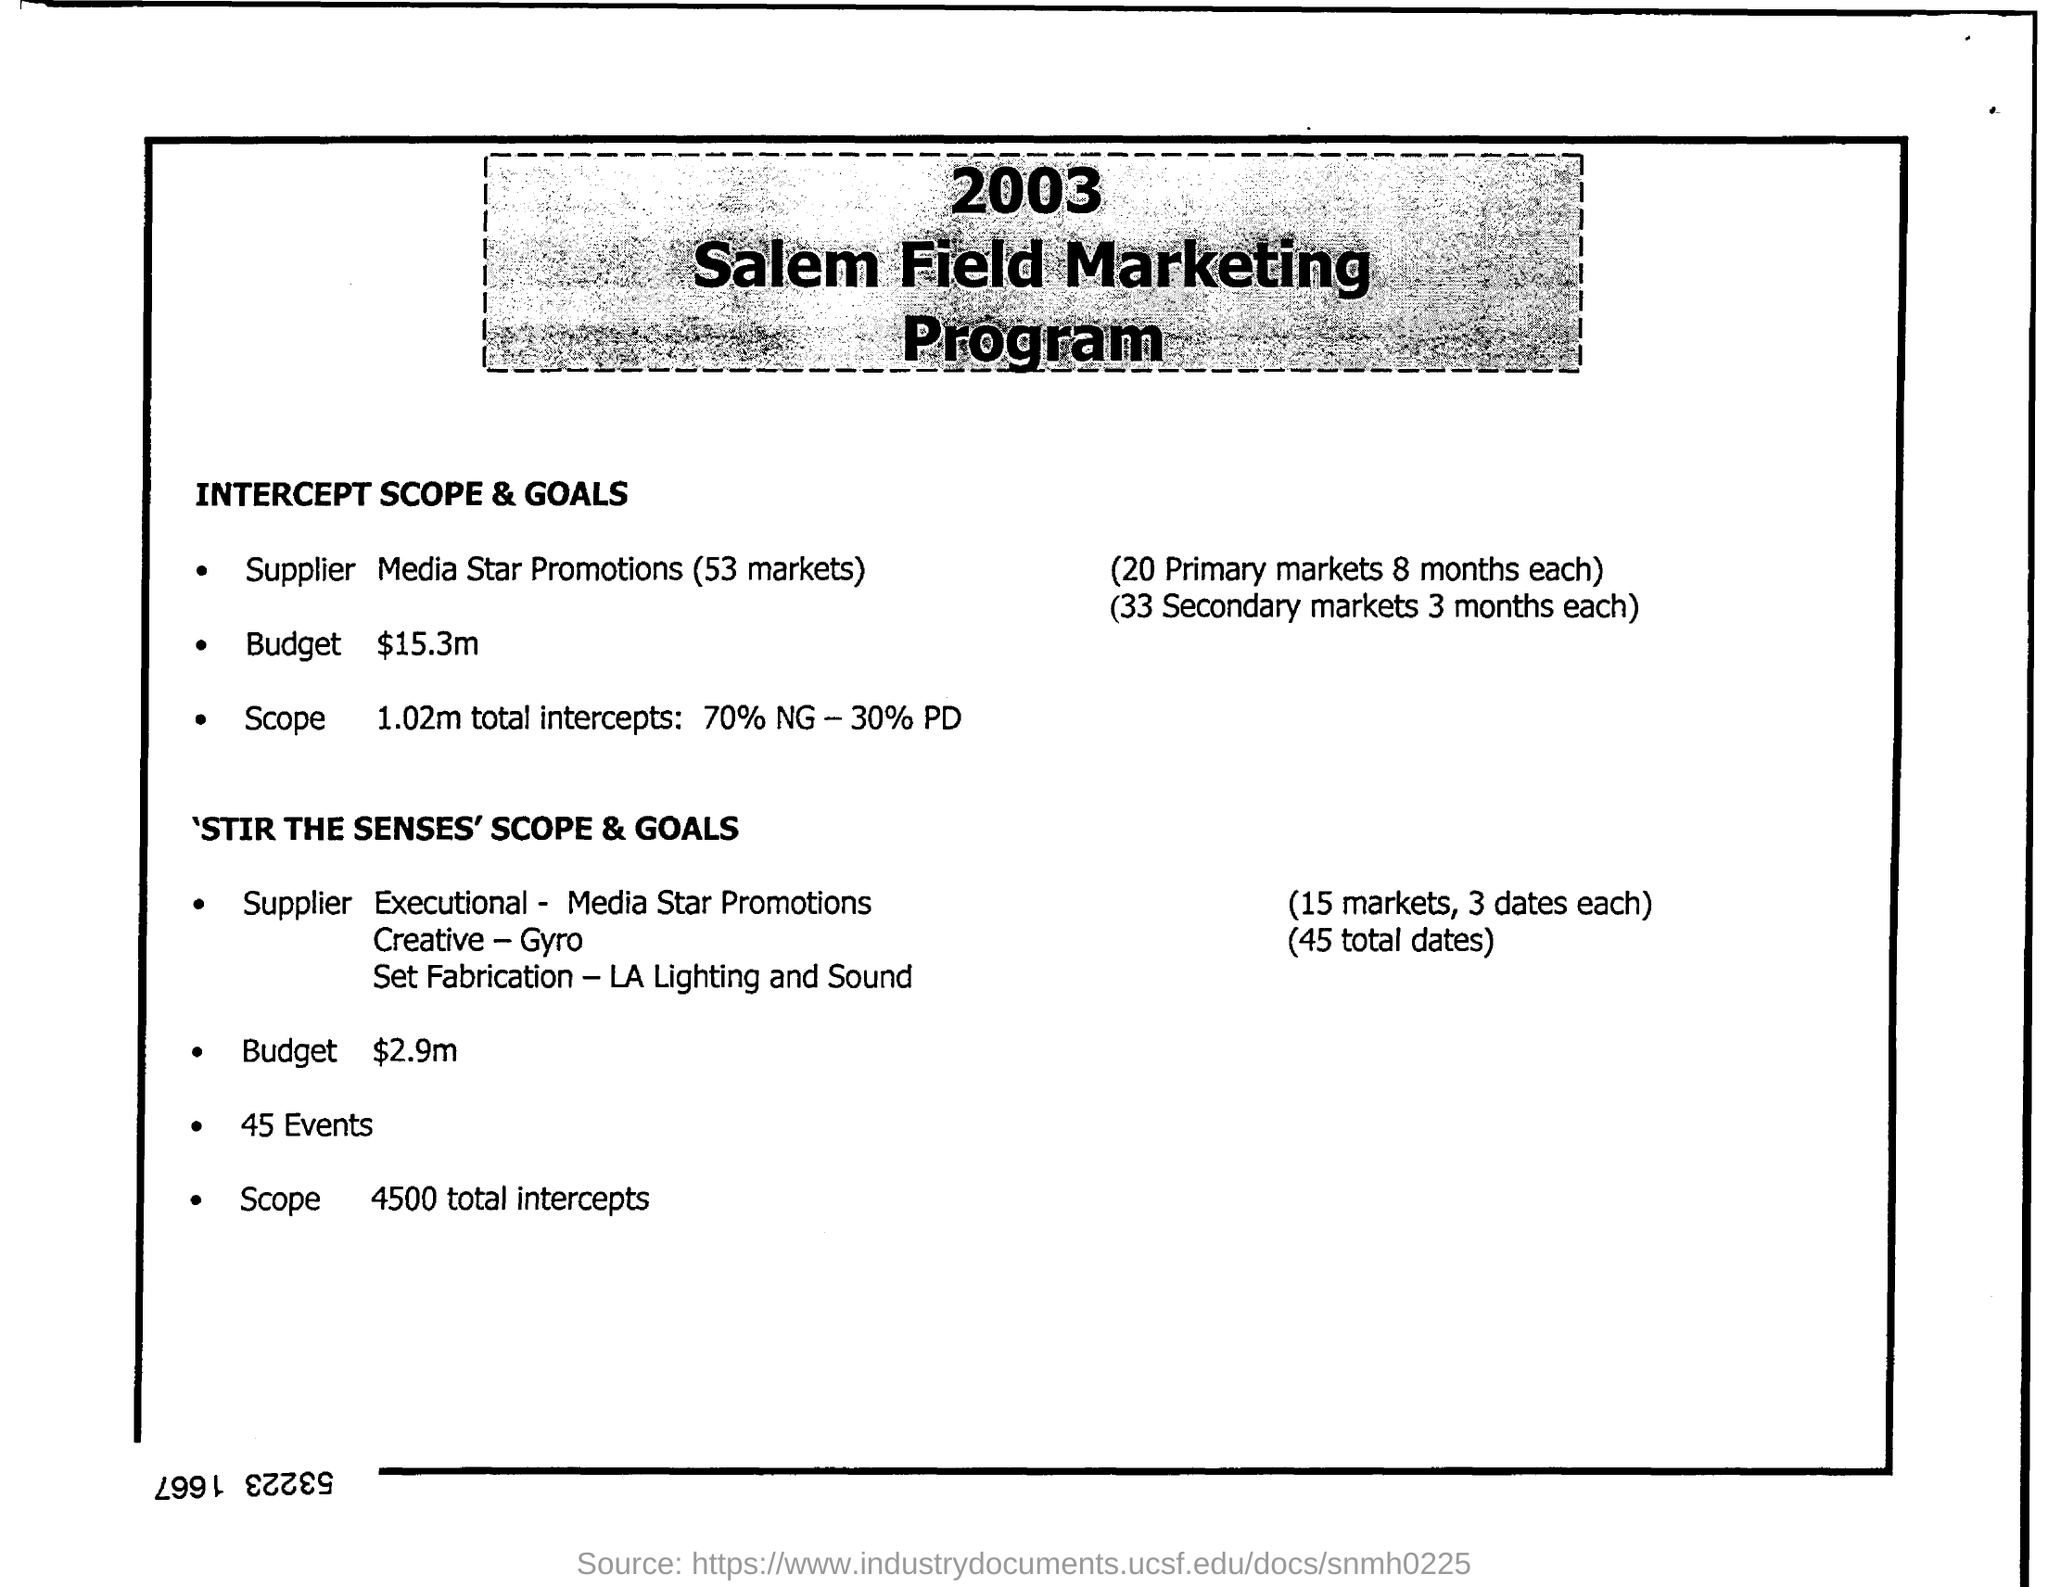Point out several critical features in this image. The name of the program is the 2003 Salem Field Marketing Program. 